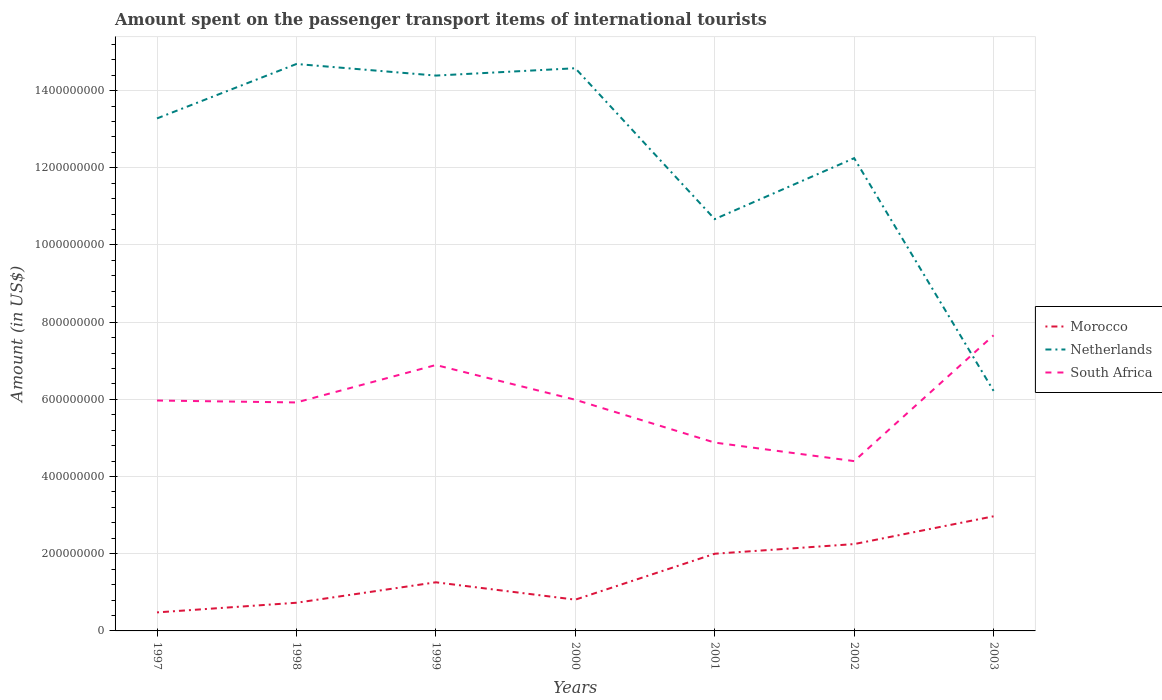Across all years, what is the maximum amount spent on the passenger transport items of international tourists in Morocco?
Offer a very short reply. 4.80e+07. In which year was the amount spent on the passenger transport items of international tourists in Morocco maximum?
Keep it short and to the point. 1997. What is the total amount spent on the passenger transport items of international tourists in Morocco in the graph?
Make the answer very short. -1.52e+08. What is the difference between the highest and the second highest amount spent on the passenger transport items of international tourists in South Africa?
Offer a terse response. 3.26e+08. Does the graph contain any zero values?
Offer a terse response. No. Where does the legend appear in the graph?
Make the answer very short. Center right. How many legend labels are there?
Provide a succinct answer. 3. What is the title of the graph?
Provide a short and direct response. Amount spent on the passenger transport items of international tourists. Does "Botswana" appear as one of the legend labels in the graph?
Your answer should be very brief. No. What is the Amount (in US$) in Morocco in 1997?
Give a very brief answer. 4.80e+07. What is the Amount (in US$) of Netherlands in 1997?
Ensure brevity in your answer.  1.33e+09. What is the Amount (in US$) in South Africa in 1997?
Keep it short and to the point. 5.97e+08. What is the Amount (in US$) in Morocco in 1998?
Your response must be concise. 7.30e+07. What is the Amount (in US$) of Netherlands in 1998?
Give a very brief answer. 1.47e+09. What is the Amount (in US$) of South Africa in 1998?
Keep it short and to the point. 5.92e+08. What is the Amount (in US$) of Morocco in 1999?
Offer a very short reply. 1.26e+08. What is the Amount (in US$) of Netherlands in 1999?
Your answer should be very brief. 1.44e+09. What is the Amount (in US$) of South Africa in 1999?
Give a very brief answer. 6.89e+08. What is the Amount (in US$) of Morocco in 2000?
Provide a succinct answer. 8.10e+07. What is the Amount (in US$) of Netherlands in 2000?
Provide a succinct answer. 1.46e+09. What is the Amount (in US$) in South Africa in 2000?
Your answer should be compact. 5.99e+08. What is the Amount (in US$) in Netherlands in 2001?
Ensure brevity in your answer.  1.07e+09. What is the Amount (in US$) in South Africa in 2001?
Your answer should be very brief. 4.88e+08. What is the Amount (in US$) in Morocco in 2002?
Offer a very short reply. 2.25e+08. What is the Amount (in US$) in Netherlands in 2002?
Ensure brevity in your answer.  1.22e+09. What is the Amount (in US$) of South Africa in 2002?
Ensure brevity in your answer.  4.40e+08. What is the Amount (in US$) of Morocco in 2003?
Give a very brief answer. 2.97e+08. What is the Amount (in US$) in Netherlands in 2003?
Offer a terse response. 6.22e+08. What is the Amount (in US$) of South Africa in 2003?
Your response must be concise. 7.66e+08. Across all years, what is the maximum Amount (in US$) of Morocco?
Your response must be concise. 2.97e+08. Across all years, what is the maximum Amount (in US$) of Netherlands?
Your response must be concise. 1.47e+09. Across all years, what is the maximum Amount (in US$) in South Africa?
Provide a short and direct response. 7.66e+08. Across all years, what is the minimum Amount (in US$) in Morocco?
Your answer should be compact. 4.80e+07. Across all years, what is the minimum Amount (in US$) of Netherlands?
Your answer should be compact. 6.22e+08. Across all years, what is the minimum Amount (in US$) of South Africa?
Offer a very short reply. 4.40e+08. What is the total Amount (in US$) in Morocco in the graph?
Keep it short and to the point. 1.05e+09. What is the total Amount (in US$) in Netherlands in the graph?
Give a very brief answer. 8.61e+09. What is the total Amount (in US$) in South Africa in the graph?
Provide a short and direct response. 4.17e+09. What is the difference between the Amount (in US$) in Morocco in 1997 and that in 1998?
Ensure brevity in your answer.  -2.50e+07. What is the difference between the Amount (in US$) in Netherlands in 1997 and that in 1998?
Keep it short and to the point. -1.41e+08. What is the difference between the Amount (in US$) of Morocco in 1997 and that in 1999?
Make the answer very short. -7.80e+07. What is the difference between the Amount (in US$) of Netherlands in 1997 and that in 1999?
Ensure brevity in your answer.  -1.11e+08. What is the difference between the Amount (in US$) of South Africa in 1997 and that in 1999?
Your answer should be compact. -9.20e+07. What is the difference between the Amount (in US$) of Morocco in 1997 and that in 2000?
Offer a very short reply. -3.30e+07. What is the difference between the Amount (in US$) in Netherlands in 1997 and that in 2000?
Offer a terse response. -1.30e+08. What is the difference between the Amount (in US$) of Morocco in 1997 and that in 2001?
Your answer should be compact. -1.52e+08. What is the difference between the Amount (in US$) of Netherlands in 1997 and that in 2001?
Give a very brief answer. 2.61e+08. What is the difference between the Amount (in US$) in South Africa in 1997 and that in 2001?
Provide a succinct answer. 1.09e+08. What is the difference between the Amount (in US$) of Morocco in 1997 and that in 2002?
Your answer should be compact. -1.77e+08. What is the difference between the Amount (in US$) of Netherlands in 1997 and that in 2002?
Make the answer very short. 1.03e+08. What is the difference between the Amount (in US$) in South Africa in 1997 and that in 2002?
Your answer should be compact. 1.57e+08. What is the difference between the Amount (in US$) of Morocco in 1997 and that in 2003?
Your answer should be compact. -2.49e+08. What is the difference between the Amount (in US$) of Netherlands in 1997 and that in 2003?
Offer a very short reply. 7.06e+08. What is the difference between the Amount (in US$) in South Africa in 1997 and that in 2003?
Your response must be concise. -1.69e+08. What is the difference between the Amount (in US$) in Morocco in 1998 and that in 1999?
Your answer should be compact. -5.30e+07. What is the difference between the Amount (in US$) in Netherlands in 1998 and that in 1999?
Your answer should be compact. 3.00e+07. What is the difference between the Amount (in US$) in South Africa in 1998 and that in 1999?
Your answer should be very brief. -9.70e+07. What is the difference between the Amount (in US$) in Morocco in 1998 and that in 2000?
Make the answer very short. -8.00e+06. What is the difference between the Amount (in US$) in Netherlands in 1998 and that in 2000?
Provide a succinct answer. 1.10e+07. What is the difference between the Amount (in US$) of South Africa in 1998 and that in 2000?
Your answer should be very brief. -7.00e+06. What is the difference between the Amount (in US$) in Morocco in 1998 and that in 2001?
Provide a short and direct response. -1.27e+08. What is the difference between the Amount (in US$) in Netherlands in 1998 and that in 2001?
Ensure brevity in your answer.  4.02e+08. What is the difference between the Amount (in US$) of South Africa in 1998 and that in 2001?
Offer a very short reply. 1.04e+08. What is the difference between the Amount (in US$) in Morocco in 1998 and that in 2002?
Ensure brevity in your answer.  -1.52e+08. What is the difference between the Amount (in US$) of Netherlands in 1998 and that in 2002?
Provide a short and direct response. 2.44e+08. What is the difference between the Amount (in US$) in South Africa in 1998 and that in 2002?
Provide a succinct answer. 1.52e+08. What is the difference between the Amount (in US$) in Morocco in 1998 and that in 2003?
Your answer should be compact. -2.24e+08. What is the difference between the Amount (in US$) in Netherlands in 1998 and that in 2003?
Offer a very short reply. 8.47e+08. What is the difference between the Amount (in US$) in South Africa in 1998 and that in 2003?
Make the answer very short. -1.74e+08. What is the difference between the Amount (in US$) of Morocco in 1999 and that in 2000?
Provide a short and direct response. 4.50e+07. What is the difference between the Amount (in US$) of Netherlands in 1999 and that in 2000?
Offer a terse response. -1.90e+07. What is the difference between the Amount (in US$) in South Africa in 1999 and that in 2000?
Your answer should be compact. 9.00e+07. What is the difference between the Amount (in US$) in Morocco in 1999 and that in 2001?
Your response must be concise. -7.40e+07. What is the difference between the Amount (in US$) in Netherlands in 1999 and that in 2001?
Offer a very short reply. 3.72e+08. What is the difference between the Amount (in US$) of South Africa in 1999 and that in 2001?
Provide a short and direct response. 2.01e+08. What is the difference between the Amount (in US$) of Morocco in 1999 and that in 2002?
Offer a terse response. -9.90e+07. What is the difference between the Amount (in US$) of Netherlands in 1999 and that in 2002?
Offer a terse response. 2.14e+08. What is the difference between the Amount (in US$) of South Africa in 1999 and that in 2002?
Give a very brief answer. 2.49e+08. What is the difference between the Amount (in US$) of Morocco in 1999 and that in 2003?
Offer a terse response. -1.71e+08. What is the difference between the Amount (in US$) of Netherlands in 1999 and that in 2003?
Give a very brief answer. 8.17e+08. What is the difference between the Amount (in US$) in South Africa in 1999 and that in 2003?
Your answer should be very brief. -7.70e+07. What is the difference between the Amount (in US$) in Morocco in 2000 and that in 2001?
Your answer should be very brief. -1.19e+08. What is the difference between the Amount (in US$) of Netherlands in 2000 and that in 2001?
Keep it short and to the point. 3.91e+08. What is the difference between the Amount (in US$) of South Africa in 2000 and that in 2001?
Your response must be concise. 1.11e+08. What is the difference between the Amount (in US$) of Morocco in 2000 and that in 2002?
Your answer should be compact. -1.44e+08. What is the difference between the Amount (in US$) in Netherlands in 2000 and that in 2002?
Give a very brief answer. 2.33e+08. What is the difference between the Amount (in US$) of South Africa in 2000 and that in 2002?
Keep it short and to the point. 1.59e+08. What is the difference between the Amount (in US$) in Morocco in 2000 and that in 2003?
Ensure brevity in your answer.  -2.16e+08. What is the difference between the Amount (in US$) of Netherlands in 2000 and that in 2003?
Provide a succinct answer. 8.36e+08. What is the difference between the Amount (in US$) in South Africa in 2000 and that in 2003?
Keep it short and to the point. -1.67e+08. What is the difference between the Amount (in US$) in Morocco in 2001 and that in 2002?
Your answer should be very brief. -2.50e+07. What is the difference between the Amount (in US$) of Netherlands in 2001 and that in 2002?
Your response must be concise. -1.58e+08. What is the difference between the Amount (in US$) of South Africa in 2001 and that in 2002?
Your answer should be compact. 4.80e+07. What is the difference between the Amount (in US$) of Morocco in 2001 and that in 2003?
Keep it short and to the point. -9.70e+07. What is the difference between the Amount (in US$) of Netherlands in 2001 and that in 2003?
Your answer should be very brief. 4.45e+08. What is the difference between the Amount (in US$) of South Africa in 2001 and that in 2003?
Your answer should be compact. -2.78e+08. What is the difference between the Amount (in US$) of Morocco in 2002 and that in 2003?
Your answer should be very brief. -7.20e+07. What is the difference between the Amount (in US$) in Netherlands in 2002 and that in 2003?
Provide a succinct answer. 6.03e+08. What is the difference between the Amount (in US$) in South Africa in 2002 and that in 2003?
Ensure brevity in your answer.  -3.26e+08. What is the difference between the Amount (in US$) of Morocco in 1997 and the Amount (in US$) of Netherlands in 1998?
Your answer should be compact. -1.42e+09. What is the difference between the Amount (in US$) in Morocco in 1997 and the Amount (in US$) in South Africa in 1998?
Your answer should be very brief. -5.44e+08. What is the difference between the Amount (in US$) in Netherlands in 1997 and the Amount (in US$) in South Africa in 1998?
Your answer should be compact. 7.36e+08. What is the difference between the Amount (in US$) of Morocco in 1997 and the Amount (in US$) of Netherlands in 1999?
Keep it short and to the point. -1.39e+09. What is the difference between the Amount (in US$) in Morocco in 1997 and the Amount (in US$) in South Africa in 1999?
Offer a terse response. -6.41e+08. What is the difference between the Amount (in US$) of Netherlands in 1997 and the Amount (in US$) of South Africa in 1999?
Your answer should be very brief. 6.39e+08. What is the difference between the Amount (in US$) of Morocco in 1997 and the Amount (in US$) of Netherlands in 2000?
Provide a short and direct response. -1.41e+09. What is the difference between the Amount (in US$) of Morocco in 1997 and the Amount (in US$) of South Africa in 2000?
Your answer should be compact. -5.51e+08. What is the difference between the Amount (in US$) of Netherlands in 1997 and the Amount (in US$) of South Africa in 2000?
Provide a short and direct response. 7.29e+08. What is the difference between the Amount (in US$) in Morocco in 1997 and the Amount (in US$) in Netherlands in 2001?
Your response must be concise. -1.02e+09. What is the difference between the Amount (in US$) in Morocco in 1997 and the Amount (in US$) in South Africa in 2001?
Offer a very short reply. -4.40e+08. What is the difference between the Amount (in US$) of Netherlands in 1997 and the Amount (in US$) of South Africa in 2001?
Offer a terse response. 8.40e+08. What is the difference between the Amount (in US$) in Morocco in 1997 and the Amount (in US$) in Netherlands in 2002?
Your answer should be compact. -1.18e+09. What is the difference between the Amount (in US$) of Morocco in 1997 and the Amount (in US$) of South Africa in 2002?
Your response must be concise. -3.92e+08. What is the difference between the Amount (in US$) in Netherlands in 1997 and the Amount (in US$) in South Africa in 2002?
Your answer should be compact. 8.88e+08. What is the difference between the Amount (in US$) in Morocco in 1997 and the Amount (in US$) in Netherlands in 2003?
Provide a short and direct response. -5.74e+08. What is the difference between the Amount (in US$) in Morocco in 1997 and the Amount (in US$) in South Africa in 2003?
Offer a very short reply. -7.18e+08. What is the difference between the Amount (in US$) of Netherlands in 1997 and the Amount (in US$) of South Africa in 2003?
Your answer should be compact. 5.62e+08. What is the difference between the Amount (in US$) of Morocco in 1998 and the Amount (in US$) of Netherlands in 1999?
Ensure brevity in your answer.  -1.37e+09. What is the difference between the Amount (in US$) of Morocco in 1998 and the Amount (in US$) of South Africa in 1999?
Offer a terse response. -6.16e+08. What is the difference between the Amount (in US$) in Netherlands in 1998 and the Amount (in US$) in South Africa in 1999?
Ensure brevity in your answer.  7.80e+08. What is the difference between the Amount (in US$) in Morocco in 1998 and the Amount (in US$) in Netherlands in 2000?
Offer a very short reply. -1.38e+09. What is the difference between the Amount (in US$) of Morocco in 1998 and the Amount (in US$) of South Africa in 2000?
Your answer should be very brief. -5.26e+08. What is the difference between the Amount (in US$) in Netherlands in 1998 and the Amount (in US$) in South Africa in 2000?
Your answer should be compact. 8.70e+08. What is the difference between the Amount (in US$) in Morocco in 1998 and the Amount (in US$) in Netherlands in 2001?
Give a very brief answer. -9.94e+08. What is the difference between the Amount (in US$) of Morocco in 1998 and the Amount (in US$) of South Africa in 2001?
Offer a very short reply. -4.15e+08. What is the difference between the Amount (in US$) of Netherlands in 1998 and the Amount (in US$) of South Africa in 2001?
Ensure brevity in your answer.  9.81e+08. What is the difference between the Amount (in US$) in Morocco in 1998 and the Amount (in US$) in Netherlands in 2002?
Provide a succinct answer. -1.15e+09. What is the difference between the Amount (in US$) of Morocco in 1998 and the Amount (in US$) of South Africa in 2002?
Make the answer very short. -3.67e+08. What is the difference between the Amount (in US$) of Netherlands in 1998 and the Amount (in US$) of South Africa in 2002?
Offer a terse response. 1.03e+09. What is the difference between the Amount (in US$) of Morocco in 1998 and the Amount (in US$) of Netherlands in 2003?
Offer a terse response. -5.49e+08. What is the difference between the Amount (in US$) of Morocco in 1998 and the Amount (in US$) of South Africa in 2003?
Provide a succinct answer. -6.93e+08. What is the difference between the Amount (in US$) of Netherlands in 1998 and the Amount (in US$) of South Africa in 2003?
Keep it short and to the point. 7.03e+08. What is the difference between the Amount (in US$) in Morocco in 1999 and the Amount (in US$) in Netherlands in 2000?
Offer a terse response. -1.33e+09. What is the difference between the Amount (in US$) in Morocco in 1999 and the Amount (in US$) in South Africa in 2000?
Ensure brevity in your answer.  -4.73e+08. What is the difference between the Amount (in US$) of Netherlands in 1999 and the Amount (in US$) of South Africa in 2000?
Ensure brevity in your answer.  8.40e+08. What is the difference between the Amount (in US$) in Morocco in 1999 and the Amount (in US$) in Netherlands in 2001?
Ensure brevity in your answer.  -9.41e+08. What is the difference between the Amount (in US$) of Morocco in 1999 and the Amount (in US$) of South Africa in 2001?
Offer a very short reply. -3.62e+08. What is the difference between the Amount (in US$) in Netherlands in 1999 and the Amount (in US$) in South Africa in 2001?
Provide a succinct answer. 9.51e+08. What is the difference between the Amount (in US$) in Morocco in 1999 and the Amount (in US$) in Netherlands in 2002?
Your answer should be compact. -1.10e+09. What is the difference between the Amount (in US$) in Morocco in 1999 and the Amount (in US$) in South Africa in 2002?
Your answer should be compact. -3.14e+08. What is the difference between the Amount (in US$) of Netherlands in 1999 and the Amount (in US$) of South Africa in 2002?
Keep it short and to the point. 9.99e+08. What is the difference between the Amount (in US$) of Morocco in 1999 and the Amount (in US$) of Netherlands in 2003?
Keep it short and to the point. -4.96e+08. What is the difference between the Amount (in US$) in Morocco in 1999 and the Amount (in US$) in South Africa in 2003?
Provide a short and direct response. -6.40e+08. What is the difference between the Amount (in US$) in Netherlands in 1999 and the Amount (in US$) in South Africa in 2003?
Provide a short and direct response. 6.73e+08. What is the difference between the Amount (in US$) in Morocco in 2000 and the Amount (in US$) in Netherlands in 2001?
Ensure brevity in your answer.  -9.86e+08. What is the difference between the Amount (in US$) in Morocco in 2000 and the Amount (in US$) in South Africa in 2001?
Ensure brevity in your answer.  -4.07e+08. What is the difference between the Amount (in US$) of Netherlands in 2000 and the Amount (in US$) of South Africa in 2001?
Make the answer very short. 9.70e+08. What is the difference between the Amount (in US$) in Morocco in 2000 and the Amount (in US$) in Netherlands in 2002?
Offer a terse response. -1.14e+09. What is the difference between the Amount (in US$) in Morocco in 2000 and the Amount (in US$) in South Africa in 2002?
Your response must be concise. -3.59e+08. What is the difference between the Amount (in US$) of Netherlands in 2000 and the Amount (in US$) of South Africa in 2002?
Offer a terse response. 1.02e+09. What is the difference between the Amount (in US$) of Morocco in 2000 and the Amount (in US$) of Netherlands in 2003?
Your answer should be compact. -5.41e+08. What is the difference between the Amount (in US$) of Morocco in 2000 and the Amount (in US$) of South Africa in 2003?
Keep it short and to the point. -6.85e+08. What is the difference between the Amount (in US$) of Netherlands in 2000 and the Amount (in US$) of South Africa in 2003?
Your response must be concise. 6.92e+08. What is the difference between the Amount (in US$) in Morocco in 2001 and the Amount (in US$) in Netherlands in 2002?
Make the answer very short. -1.02e+09. What is the difference between the Amount (in US$) of Morocco in 2001 and the Amount (in US$) of South Africa in 2002?
Your response must be concise. -2.40e+08. What is the difference between the Amount (in US$) of Netherlands in 2001 and the Amount (in US$) of South Africa in 2002?
Provide a succinct answer. 6.27e+08. What is the difference between the Amount (in US$) of Morocco in 2001 and the Amount (in US$) of Netherlands in 2003?
Your answer should be very brief. -4.22e+08. What is the difference between the Amount (in US$) in Morocco in 2001 and the Amount (in US$) in South Africa in 2003?
Offer a very short reply. -5.66e+08. What is the difference between the Amount (in US$) in Netherlands in 2001 and the Amount (in US$) in South Africa in 2003?
Give a very brief answer. 3.01e+08. What is the difference between the Amount (in US$) of Morocco in 2002 and the Amount (in US$) of Netherlands in 2003?
Provide a succinct answer. -3.97e+08. What is the difference between the Amount (in US$) in Morocco in 2002 and the Amount (in US$) in South Africa in 2003?
Provide a short and direct response. -5.41e+08. What is the difference between the Amount (in US$) in Netherlands in 2002 and the Amount (in US$) in South Africa in 2003?
Provide a short and direct response. 4.59e+08. What is the average Amount (in US$) of Morocco per year?
Keep it short and to the point. 1.50e+08. What is the average Amount (in US$) of Netherlands per year?
Offer a very short reply. 1.23e+09. What is the average Amount (in US$) of South Africa per year?
Make the answer very short. 5.96e+08. In the year 1997, what is the difference between the Amount (in US$) of Morocco and Amount (in US$) of Netherlands?
Offer a very short reply. -1.28e+09. In the year 1997, what is the difference between the Amount (in US$) of Morocco and Amount (in US$) of South Africa?
Keep it short and to the point. -5.49e+08. In the year 1997, what is the difference between the Amount (in US$) of Netherlands and Amount (in US$) of South Africa?
Keep it short and to the point. 7.31e+08. In the year 1998, what is the difference between the Amount (in US$) in Morocco and Amount (in US$) in Netherlands?
Provide a short and direct response. -1.40e+09. In the year 1998, what is the difference between the Amount (in US$) in Morocco and Amount (in US$) in South Africa?
Make the answer very short. -5.19e+08. In the year 1998, what is the difference between the Amount (in US$) of Netherlands and Amount (in US$) of South Africa?
Keep it short and to the point. 8.77e+08. In the year 1999, what is the difference between the Amount (in US$) of Morocco and Amount (in US$) of Netherlands?
Provide a short and direct response. -1.31e+09. In the year 1999, what is the difference between the Amount (in US$) in Morocco and Amount (in US$) in South Africa?
Provide a succinct answer. -5.63e+08. In the year 1999, what is the difference between the Amount (in US$) of Netherlands and Amount (in US$) of South Africa?
Your answer should be compact. 7.50e+08. In the year 2000, what is the difference between the Amount (in US$) of Morocco and Amount (in US$) of Netherlands?
Give a very brief answer. -1.38e+09. In the year 2000, what is the difference between the Amount (in US$) in Morocco and Amount (in US$) in South Africa?
Your answer should be compact. -5.18e+08. In the year 2000, what is the difference between the Amount (in US$) of Netherlands and Amount (in US$) of South Africa?
Keep it short and to the point. 8.59e+08. In the year 2001, what is the difference between the Amount (in US$) of Morocco and Amount (in US$) of Netherlands?
Provide a succinct answer. -8.67e+08. In the year 2001, what is the difference between the Amount (in US$) in Morocco and Amount (in US$) in South Africa?
Your answer should be very brief. -2.88e+08. In the year 2001, what is the difference between the Amount (in US$) in Netherlands and Amount (in US$) in South Africa?
Keep it short and to the point. 5.79e+08. In the year 2002, what is the difference between the Amount (in US$) of Morocco and Amount (in US$) of Netherlands?
Offer a terse response. -1.00e+09. In the year 2002, what is the difference between the Amount (in US$) of Morocco and Amount (in US$) of South Africa?
Offer a terse response. -2.15e+08. In the year 2002, what is the difference between the Amount (in US$) of Netherlands and Amount (in US$) of South Africa?
Your response must be concise. 7.85e+08. In the year 2003, what is the difference between the Amount (in US$) of Morocco and Amount (in US$) of Netherlands?
Your response must be concise. -3.25e+08. In the year 2003, what is the difference between the Amount (in US$) of Morocco and Amount (in US$) of South Africa?
Your response must be concise. -4.69e+08. In the year 2003, what is the difference between the Amount (in US$) of Netherlands and Amount (in US$) of South Africa?
Make the answer very short. -1.44e+08. What is the ratio of the Amount (in US$) in Morocco in 1997 to that in 1998?
Provide a succinct answer. 0.66. What is the ratio of the Amount (in US$) in Netherlands in 1997 to that in 1998?
Provide a short and direct response. 0.9. What is the ratio of the Amount (in US$) in South Africa in 1997 to that in 1998?
Provide a short and direct response. 1.01. What is the ratio of the Amount (in US$) in Morocco in 1997 to that in 1999?
Ensure brevity in your answer.  0.38. What is the ratio of the Amount (in US$) of Netherlands in 1997 to that in 1999?
Make the answer very short. 0.92. What is the ratio of the Amount (in US$) in South Africa in 1997 to that in 1999?
Offer a terse response. 0.87. What is the ratio of the Amount (in US$) in Morocco in 1997 to that in 2000?
Give a very brief answer. 0.59. What is the ratio of the Amount (in US$) in Netherlands in 1997 to that in 2000?
Offer a terse response. 0.91. What is the ratio of the Amount (in US$) of South Africa in 1997 to that in 2000?
Offer a terse response. 1. What is the ratio of the Amount (in US$) of Morocco in 1997 to that in 2001?
Ensure brevity in your answer.  0.24. What is the ratio of the Amount (in US$) in Netherlands in 1997 to that in 2001?
Provide a succinct answer. 1.24. What is the ratio of the Amount (in US$) of South Africa in 1997 to that in 2001?
Offer a very short reply. 1.22. What is the ratio of the Amount (in US$) of Morocco in 1997 to that in 2002?
Give a very brief answer. 0.21. What is the ratio of the Amount (in US$) of Netherlands in 1997 to that in 2002?
Offer a terse response. 1.08. What is the ratio of the Amount (in US$) of South Africa in 1997 to that in 2002?
Provide a succinct answer. 1.36. What is the ratio of the Amount (in US$) of Morocco in 1997 to that in 2003?
Make the answer very short. 0.16. What is the ratio of the Amount (in US$) in Netherlands in 1997 to that in 2003?
Provide a short and direct response. 2.13. What is the ratio of the Amount (in US$) of South Africa in 1997 to that in 2003?
Offer a terse response. 0.78. What is the ratio of the Amount (in US$) in Morocco in 1998 to that in 1999?
Your answer should be compact. 0.58. What is the ratio of the Amount (in US$) of Netherlands in 1998 to that in 1999?
Offer a very short reply. 1.02. What is the ratio of the Amount (in US$) in South Africa in 1998 to that in 1999?
Provide a short and direct response. 0.86. What is the ratio of the Amount (in US$) of Morocco in 1998 to that in 2000?
Give a very brief answer. 0.9. What is the ratio of the Amount (in US$) in Netherlands in 1998 to that in 2000?
Offer a terse response. 1.01. What is the ratio of the Amount (in US$) in South Africa in 1998 to that in 2000?
Your answer should be very brief. 0.99. What is the ratio of the Amount (in US$) of Morocco in 1998 to that in 2001?
Offer a terse response. 0.36. What is the ratio of the Amount (in US$) in Netherlands in 1998 to that in 2001?
Your response must be concise. 1.38. What is the ratio of the Amount (in US$) in South Africa in 1998 to that in 2001?
Your answer should be compact. 1.21. What is the ratio of the Amount (in US$) in Morocco in 1998 to that in 2002?
Ensure brevity in your answer.  0.32. What is the ratio of the Amount (in US$) of Netherlands in 1998 to that in 2002?
Offer a very short reply. 1.2. What is the ratio of the Amount (in US$) of South Africa in 1998 to that in 2002?
Give a very brief answer. 1.35. What is the ratio of the Amount (in US$) of Morocco in 1998 to that in 2003?
Your response must be concise. 0.25. What is the ratio of the Amount (in US$) of Netherlands in 1998 to that in 2003?
Give a very brief answer. 2.36. What is the ratio of the Amount (in US$) in South Africa in 1998 to that in 2003?
Provide a succinct answer. 0.77. What is the ratio of the Amount (in US$) of Morocco in 1999 to that in 2000?
Keep it short and to the point. 1.56. What is the ratio of the Amount (in US$) in South Africa in 1999 to that in 2000?
Provide a short and direct response. 1.15. What is the ratio of the Amount (in US$) in Morocco in 1999 to that in 2001?
Make the answer very short. 0.63. What is the ratio of the Amount (in US$) in Netherlands in 1999 to that in 2001?
Provide a short and direct response. 1.35. What is the ratio of the Amount (in US$) in South Africa in 1999 to that in 2001?
Your response must be concise. 1.41. What is the ratio of the Amount (in US$) of Morocco in 1999 to that in 2002?
Provide a short and direct response. 0.56. What is the ratio of the Amount (in US$) of Netherlands in 1999 to that in 2002?
Give a very brief answer. 1.17. What is the ratio of the Amount (in US$) in South Africa in 1999 to that in 2002?
Your answer should be compact. 1.57. What is the ratio of the Amount (in US$) of Morocco in 1999 to that in 2003?
Offer a very short reply. 0.42. What is the ratio of the Amount (in US$) of Netherlands in 1999 to that in 2003?
Provide a short and direct response. 2.31. What is the ratio of the Amount (in US$) of South Africa in 1999 to that in 2003?
Provide a succinct answer. 0.9. What is the ratio of the Amount (in US$) in Morocco in 2000 to that in 2001?
Offer a terse response. 0.41. What is the ratio of the Amount (in US$) in Netherlands in 2000 to that in 2001?
Provide a succinct answer. 1.37. What is the ratio of the Amount (in US$) of South Africa in 2000 to that in 2001?
Give a very brief answer. 1.23. What is the ratio of the Amount (in US$) of Morocco in 2000 to that in 2002?
Provide a succinct answer. 0.36. What is the ratio of the Amount (in US$) of Netherlands in 2000 to that in 2002?
Your response must be concise. 1.19. What is the ratio of the Amount (in US$) in South Africa in 2000 to that in 2002?
Provide a short and direct response. 1.36. What is the ratio of the Amount (in US$) in Morocco in 2000 to that in 2003?
Your response must be concise. 0.27. What is the ratio of the Amount (in US$) of Netherlands in 2000 to that in 2003?
Ensure brevity in your answer.  2.34. What is the ratio of the Amount (in US$) in South Africa in 2000 to that in 2003?
Ensure brevity in your answer.  0.78. What is the ratio of the Amount (in US$) of Netherlands in 2001 to that in 2002?
Keep it short and to the point. 0.87. What is the ratio of the Amount (in US$) of South Africa in 2001 to that in 2002?
Your response must be concise. 1.11. What is the ratio of the Amount (in US$) of Morocco in 2001 to that in 2003?
Ensure brevity in your answer.  0.67. What is the ratio of the Amount (in US$) in Netherlands in 2001 to that in 2003?
Make the answer very short. 1.72. What is the ratio of the Amount (in US$) in South Africa in 2001 to that in 2003?
Your response must be concise. 0.64. What is the ratio of the Amount (in US$) of Morocco in 2002 to that in 2003?
Keep it short and to the point. 0.76. What is the ratio of the Amount (in US$) in Netherlands in 2002 to that in 2003?
Your response must be concise. 1.97. What is the ratio of the Amount (in US$) in South Africa in 2002 to that in 2003?
Your answer should be compact. 0.57. What is the difference between the highest and the second highest Amount (in US$) in Morocco?
Ensure brevity in your answer.  7.20e+07. What is the difference between the highest and the second highest Amount (in US$) in Netherlands?
Offer a very short reply. 1.10e+07. What is the difference between the highest and the second highest Amount (in US$) of South Africa?
Provide a succinct answer. 7.70e+07. What is the difference between the highest and the lowest Amount (in US$) in Morocco?
Your answer should be compact. 2.49e+08. What is the difference between the highest and the lowest Amount (in US$) in Netherlands?
Your answer should be very brief. 8.47e+08. What is the difference between the highest and the lowest Amount (in US$) of South Africa?
Your response must be concise. 3.26e+08. 